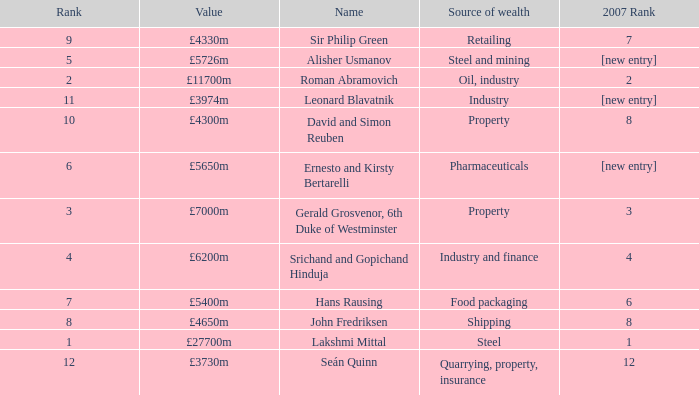What source of wealth has a value of £5726m? Steel and mining. 